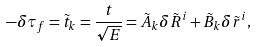Convert formula to latex. <formula><loc_0><loc_0><loc_500><loc_500>- \delta \tau _ { f } = \tilde { t } _ { k } = \frac { t } { \sqrt { E } } = \tilde { A } _ { k } \delta \tilde { R } ^ { i } + \tilde { B } _ { k } \delta \tilde { r } ^ { i } ,</formula> 